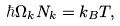<formula> <loc_0><loc_0><loc_500><loc_500>\hbar { \Omega } _ { k } N _ { k } = k _ { B } T ,</formula> 